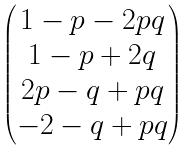Convert formula to latex. <formula><loc_0><loc_0><loc_500><loc_500>\begin{pmatrix} 1 - p - 2 p q \\ 1 - p + 2 q \\ 2 p - q + p q \\ - 2 - q + p q \end{pmatrix}</formula> 